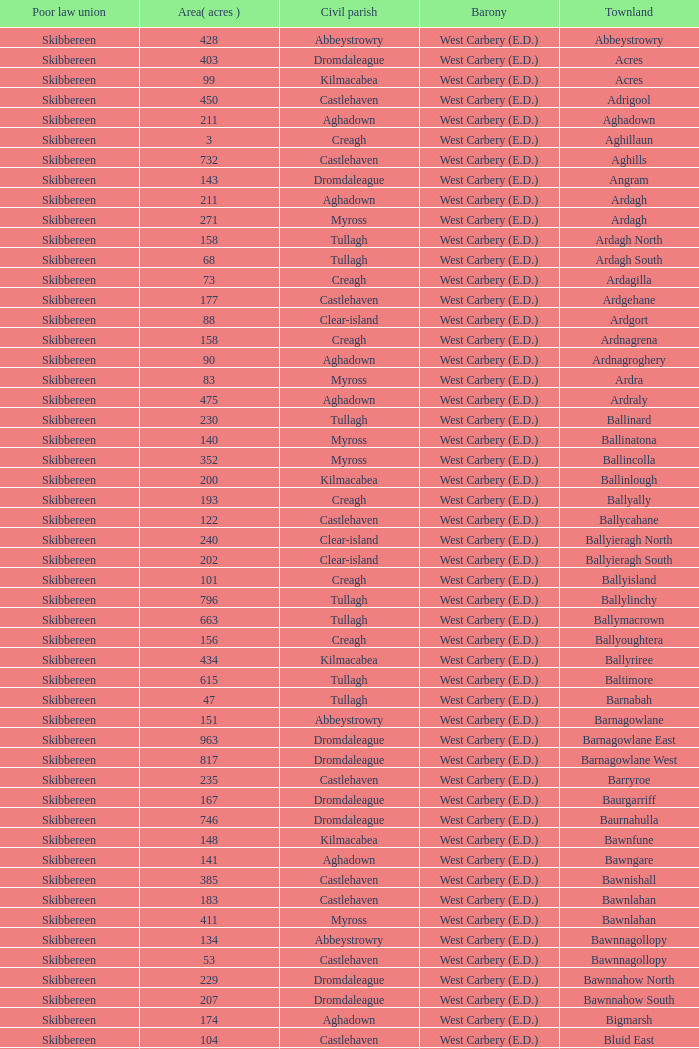What are the Poor Law Unions when the area (in acres) is 142? Skibbereen. 